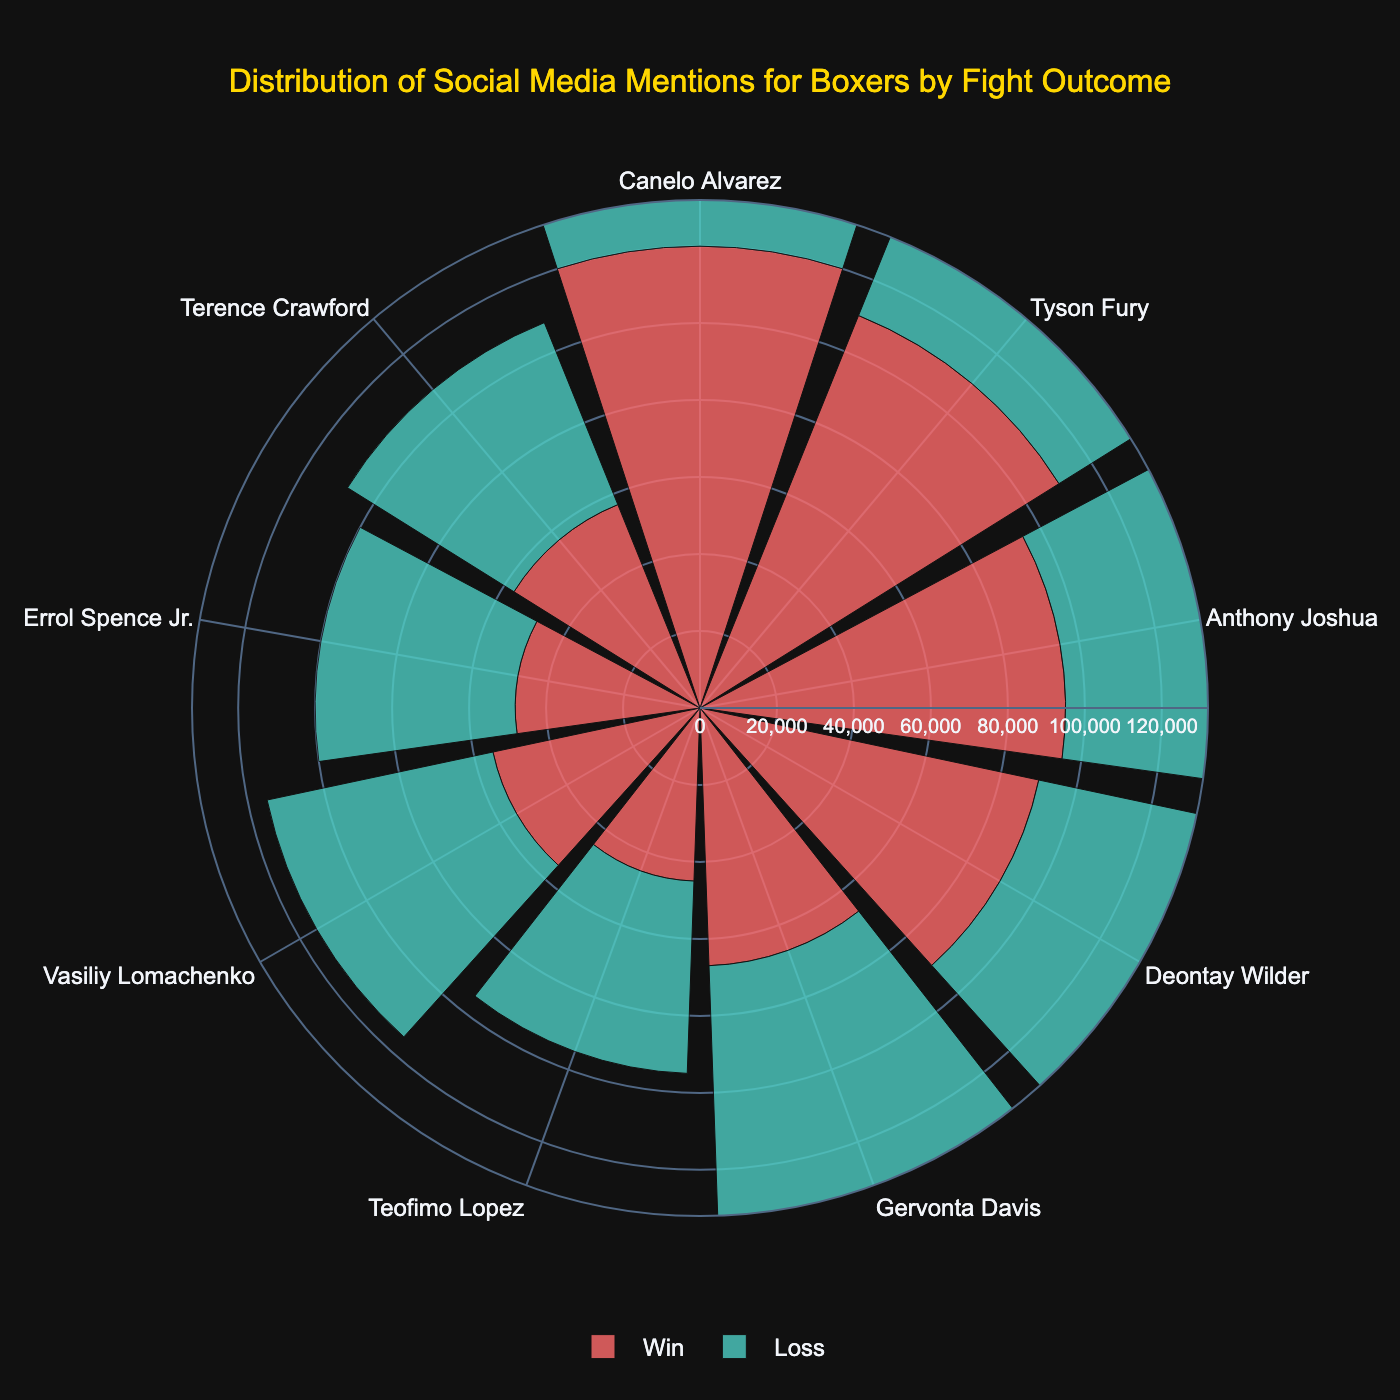What is the title of the rose chart? The title is displayed at the top of the figure in larger, bold text. It provides a summary of what the chart represents.
Answer: Distribution of Social Media Mentions for Boxers by Fight Outcome Which boxer had the highest number of social media mentions for a win? Look for the longest bar in the section labeled "Win." The corresponding boxer's name is noted along the angular axis.
Answer: Canelo Alvarez How do the social media mentions for Vasiliy Lomachenko differ between a win and a loss? Locate the bars for Vasiliy Lomachenko in both "Win" and "Loss" sections and subtract the "Win" mentions from the "Loss" mentions.
Answer: Lomachenko had 5,000 more mentions for a loss than a win Is there any boxer who has more social media mentions for a loss compared to a win? Compare the lengths of the bars in the "Win" and "Loss" sections for each boxer. Identify if a boxer's "Loss" bar is longer than the "Win" one.
Answer: Yes, Deontay Wilder What is the average number of social media mentions for wins across all boxers? Add the number of mentions for all boxers in the "Win" section and divide by the number of boxers. (120,000+110,000+95,000+90,000+67,000+45,000+55,000+48,000+57,000) / 9
Answer: 76,444 Which boxers have social media mentions exceeding 100,000 in any outcome? Identify the boxers with bars extending beyond 100,000 mentions in either the "Win" or "Loss" section.
Answer: Canelo Alvarez, Tyson Fury Who received fewer mentions when winning compared to Teofimo Lopez's losing mentions? Compare the bars in the "Win" section to the mentions of Teofimo Lopez's loss (50,000) noted in the "Loss" section. Identify any boxers with bars shorter than 50,000.
Answer: Gervonta Davis, Teofimo Lopez, Vasiliy Lomachenko, Errol Spence Jr., Terence Crawford What is the total number of social media mentions for boxers in the "Loss" section? Sum up the number of mentions for all boxers in the "Loss" section. (80,000+85,000+88,000+92,000+73,000+50,000+60,000+52,000+51,000)
Answer: 631,000 